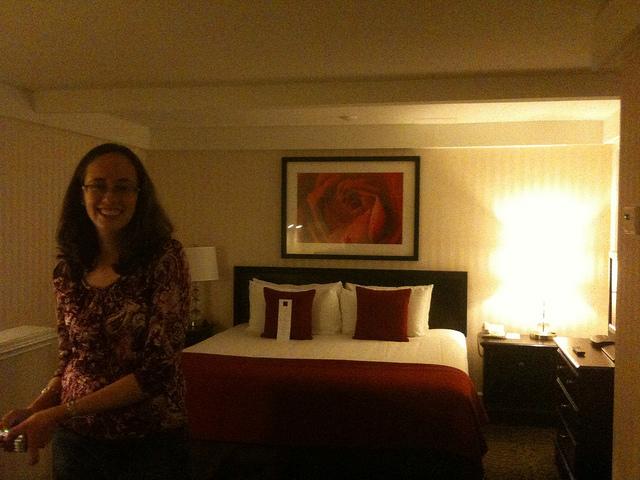Which room is this?
Quick response, please. Bedroom. What is the woman doing?
Concise answer only. Smiling. Is the person wearing glasses?
Answer briefly. Yes. Is she happy?
Quick response, please. Yes. Are there any people shown?
Write a very short answer. Yes. Is the skin golden brown?
Short answer required. No. Is there anyone in this room?
Quick response, please. Yes. 